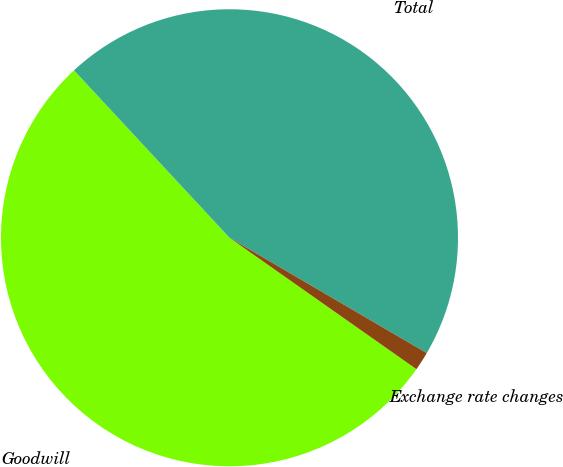<chart> <loc_0><loc_0><loc_500><loc_500><pie_chart><fcel>Goodwill<fcel>Total<fcel>Exchange rate changes<nl><fcel>53.33%<fcel>45.33%<fcel>1.33%<nl></chart> 